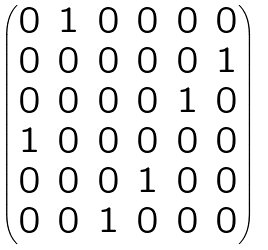Convert formula to latex. <formula><loc_0><loc_0><loc_500><loc_500>\begin{pmatrix} 0 & 1 & 0 & 0 & 0 & 0 \\ 0 & 0 & 0 & 0 & 0 & 1 \\ 0 & 0 & 0 & 0 & 1 & 0 \\ 1 & 0 & 0 & 0 & 0 & 0 \\ 0 & 0 & 0 & 1 & 0 & 0 \\ 0 & 0 & 1 & 0 & 0 & 0 \end{pmatrix}</formula> 